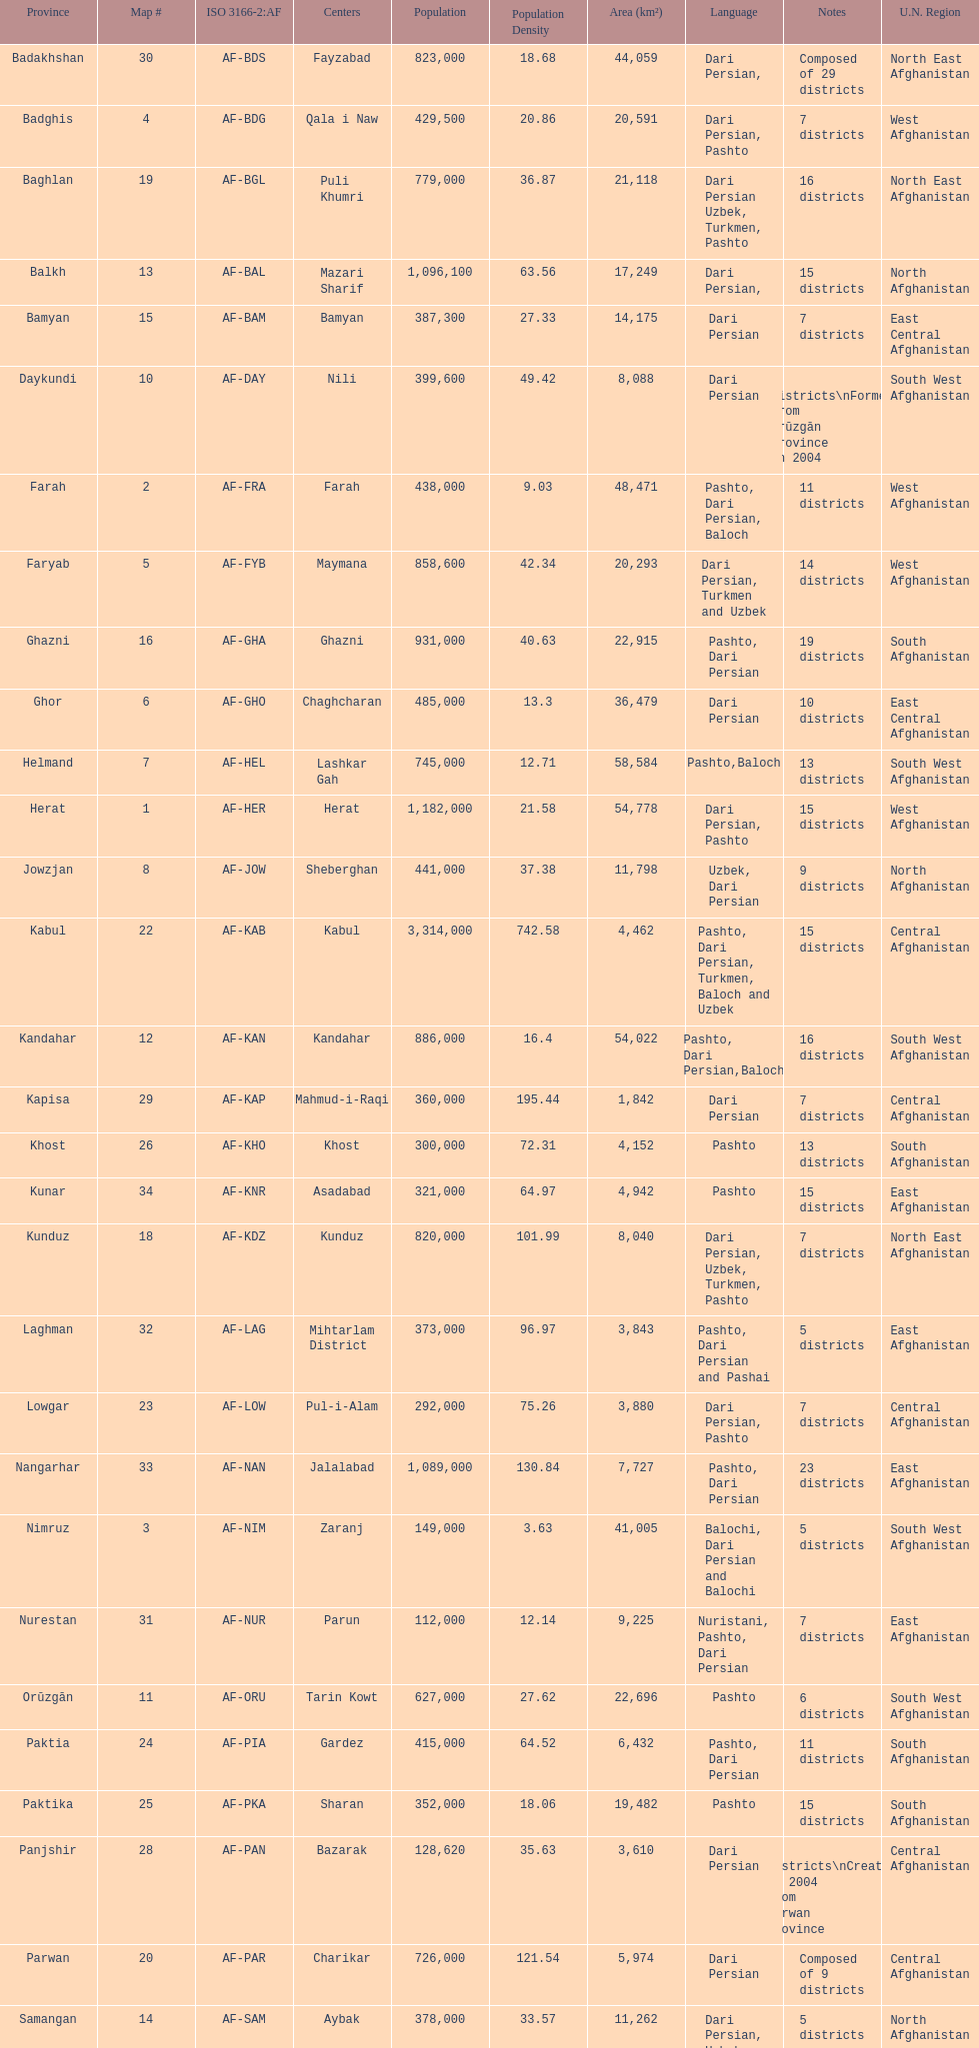How many provinces have the same number of districts as kabul? 4. 